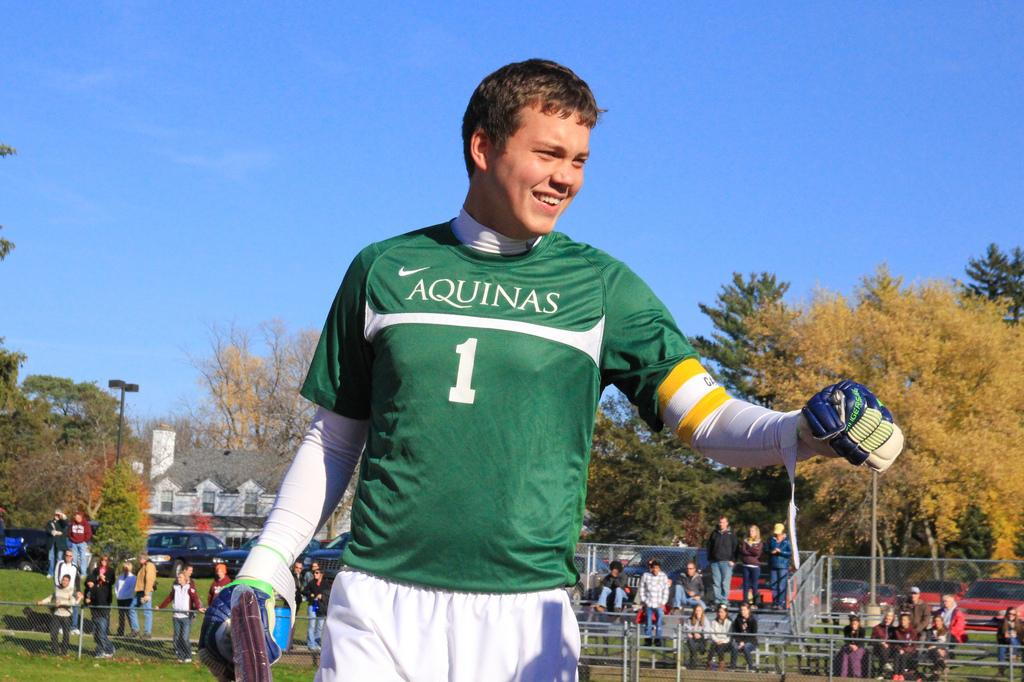<image>
Offer a succinct explanation of the picture presented. A smiling football player wearing a jersey with the Aquinas insignia and the number one emblazoned on it . 